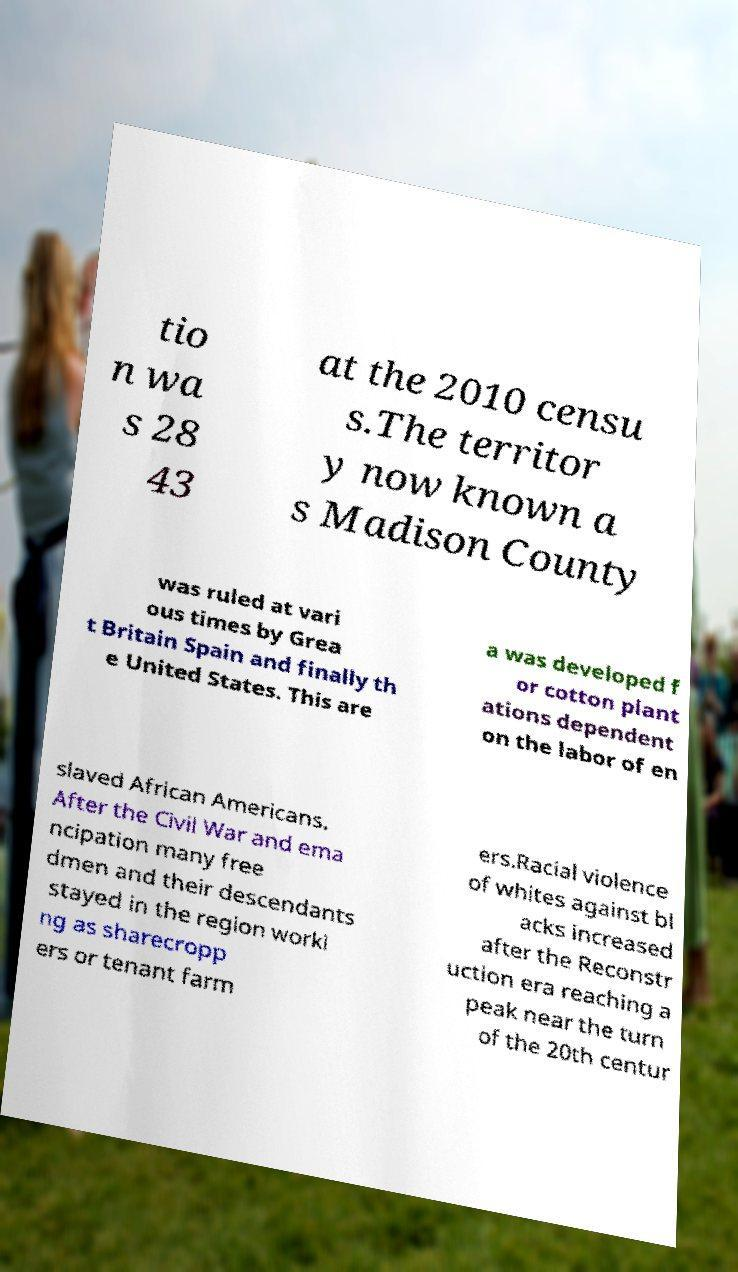Could you assist in decoding the text presented in this image and type it out clearly? tio n wa s 28 43 at the 2010 censu s.The territor y now known a s Madison County was ruled at vari ous times by Grea t Britain Spain and finally th e United States. This are a was developed f or cotton plant ations dependent on the labor of en slaved African Americans. After the Civil War and ema ncipation many free dmen and their descendants stayed in the region worki ng as sharecropp ers or tenant farm ers.Racial violence of whites against bl acks increased after the Reconstr uction era reaching a peak near the turn of the 20th centur 